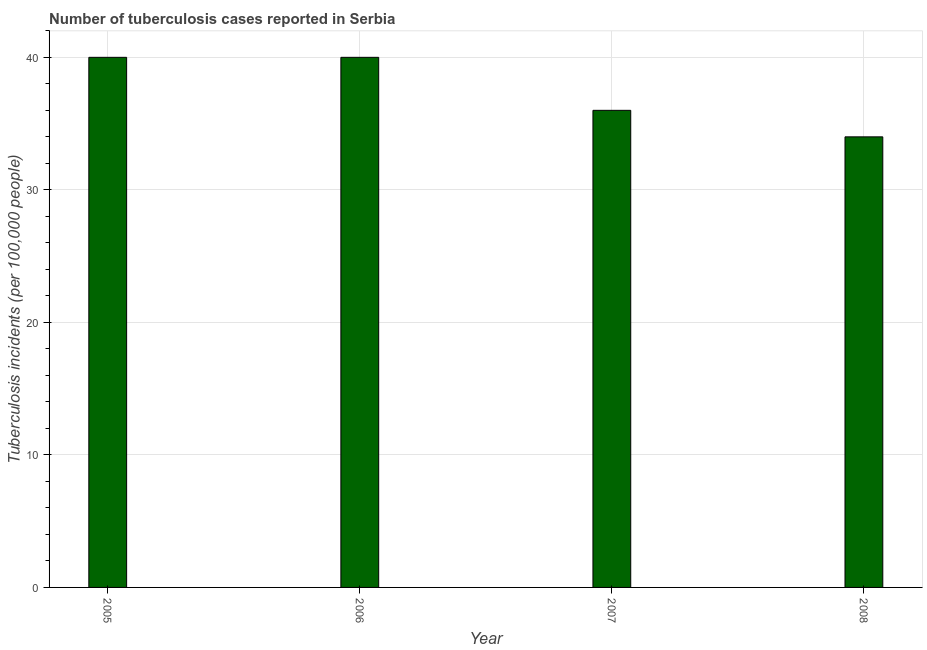What is the title of the graph?
Provide a short and direct response. Number of tuberculosis cases reported in Serbia. What is the label or title of the Y-axis?
Keep it short and to the point. Tuberculosis incidents (per 100,0 people). Across all years, what is the minimum number of tuberculosis incidents?
Provide a succinct answer. 34. In which year was the number of tuberculosis incidents maximum?
Make the answer very short. 2005. What is the sum of the number of tuberculosis incidents?
Provide a short and direct response. 150. What is the difference between the number of tuberculosis incidents in 2007 and 2008?
Provide a short and direct response. 2. What is the average number of tuberculosis incidents per year?
Your answer should be very brief. 37. Do a majority of the years between 2008 and 2007 (inclusive) have number of tuberculosis incidents greater than 40 ?
Your answer should be very brief. No. What is the ratio of the number of tuberculosis incidents in 2007 to that in 2008?
Your answer should be compact. 1.06. Is the difference between the number of tuberculosis incidents in 2005 and 2008 greater than the difference between any two years?
Provide a short and direct response. Yes. What is the difference between the highest and the second highest number of tuberculosis incidents?
Your answer should be very brief. 0. Is the sum of the number of tuberculosis incidents in 2007 and 2008 greater than the maximum number of tuberculosis incidents across all years?
Ensure brevity in your answer.  Yes. What is the difference between the highest and the lowest number of tuberculosis incidents?
Provide a succinct answer. 6. In how many years, is the number of tuberculosis incidents greater than the average number of tuberculosis incidents taken over all years?
Provide a short and direct response. 2. How many bars are there?
Your response must be concise. 4. Are all the bars in the graph horizontal?
Your response must be concise. No. What is the Tuberculosis incidents (per 100,000 people) of 2006?
Provide a short and direct response. 40. What is the Tuberculosis incidents (per 100,000 people) of 2007?
Provide a succinct answer. 36. What is the Tuberculosis incidents (per 100,000 people) of 2008?
Keep it short and to the point. 34. What is the difference between the Tuberculosis incidents (per 100,000 people) in 2005 and 2006?
Make the answer very short. 0. What is the difference between the Tuberculosis incidents (per 100,000 people) in 2005 and 2008?
Your answer should be compact. 6. What is the difference between the Tuberculosis incidents (per 100,000 people) in 2006 and 2007?
Your answer should be very brief. 4. What is the difference between the Tuberculosis incidents (per 100,000 people) in 2006 and 2008?
Provide a short and direct response. 6. What is the ratio of the Tuberculosis incidents (per 100,000 people) in 2005 to that in 2006?
Ensure brevity in your answer.  1. What is the ratio of the Tuberculosis incidents (per 100,000 people) in 2005 to that in 2007?
Offer a very short reply. 1.11. What is the ratio of the Tuberculosis incidents (per 100,000 people) in 2005 to that in 2008?
Make the answer very short. 1.18. What is the ratio of the Tuberculosis incidents (per 100,000 people) in 2006 to that in 2007?
Offer a terse response. 1.11. What is the ratio of the Tuberculosis incidents (per 100,000 people) in 2006 to that in 2008?
Provide a short and direct response. 1.18. What is the ratio of the Tuberculosis incidents (per 100,000 people) in 2007 to that in 2008?
Your answer should be compact. 1.06. 